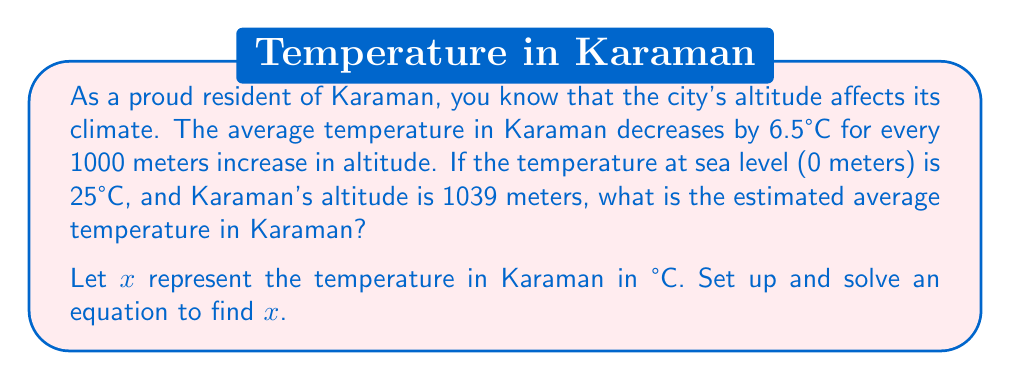Give your solution to this math problem. To solve this problem, we need to set up an equation based on the given information:

1. The temperature decreases by 6.5°C for every 1000 meters increase in altitude.
2. The temperature at sea level (0 meters) is 25°C.
3. Karaman's altitude is 1039 meters.

Let's set up the equation:

$$ x = 25 - (6.5 \times \frac{1039}{1000}) $$

Here's why:
- We start with 25°C (the temperature at sea level).
- We subtract the temperature decrease due to altitude.
- The temperature decrease is calculated by multiplying 6.5°C (the decrease per 1000 meters) by the fraction of 1039/1000 (Karaman's altitude as a fraction of 1000 meters).

Now, let's solve the equation:

$$ x = 25 - (6.5 \times 1.039) $$
$$ x = 25 - 6.7535 $$
$$ x = 18.2465 $$

Rounding to one decimal place:
$$ x \approx 18.2 $$
Answer: The estimated average temperature in Karaman is approximately 18.2°C. 